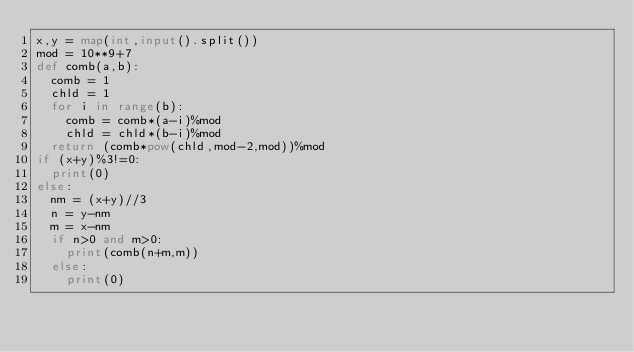Convert code to text. <code><loc_0><loc_0><loc_500><loc_500><_Python_>x,y = map(int,input().split())
mod = 10**9+7
def comb(a,b):
  comb = 1
  chld = 1
  for i in range(b):
    comb = comb*(a-i)%mod
    chld = chld*(b-i)%mod
  return (comb*pow(chld,mod-2,mod))%mod
if (x+y)%3!=0:
  print(0)
else:
  nm = (x+y)//3
  n = y-nm
  m = x-nm
  if n>0 and m>0:
    print(comb(n+m,m))
  else:
    print(0)</code> 